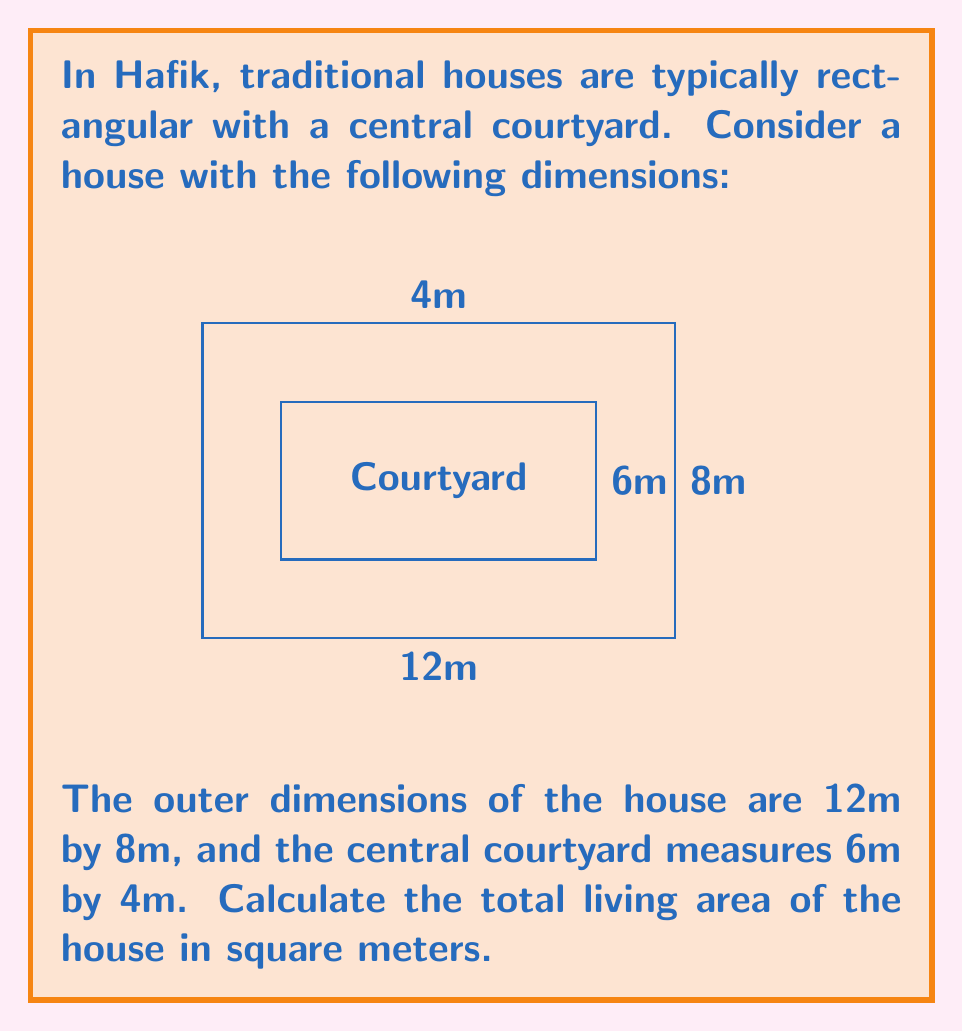Can you solve this math problem? To calculate the living area of the house, we need to follow these steps:

1. Calculate the total area of the house including the courtyard:
   $$A_{total} = 12m \times 8m = 96m^2$$

2. Calculate the area of the courtyard:
   $$A_{courtyard} = 6m \times 4m = 24m^2$$

3. Subtract the courtyard area from the total area to get the living area:
   $$A_{living} = A_{total} - A_{courtyard}$$
   $$A_{living} = 96m^2 - 24m^2 = 72m^2$$

Therefore, the total living area of the traditional Hafik house is 72 square meters.
Answer: $72m^2$ 